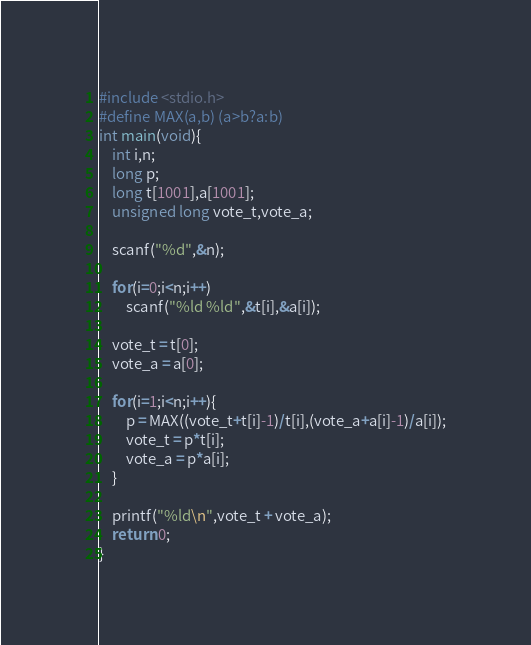Convert code to text. <code><loc_0><loc_0><loc_500><loc_500><_C_>#include <stdio.h>
#define MAX(a,b) (a>b?a:b)
int main(void){
	int i,n;
	long p;
	long t[1001],a[1001];
	unsigned long vote_t,vote_a;
	
	scanf("%d",&n);
	
	for(i=0;i<n;i++)
	    scanf("%ld %ld",&t[i],&a[i]);
	    
	vote_t = t[0];
	vote_a = a[0];
	
	for(i=1;i<n;i++){
		p = MAX((vote_t+t[i]-1)/t[i],(vote_a+a[i]-1)/a[i]);
		vote_t = p*t[i];
		vote_a = p*a[i];
	}
	
	printf("%ld\n",vote_t + vote_a);
	return 0;
}</code> 